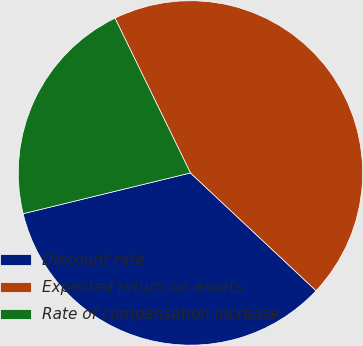Convert chart to OTSL. <chart><loc_0><loc_0><loc_500><loc_500><pie_chart><fcel>Discount rate<fcel>Expected return on assets<fcel>Rate of compensation increase<nl><fcel>34.21%<fcel>44.21%<fcel>21.58%<nl></chart> 